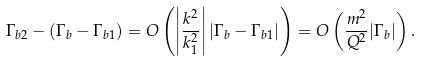<formula> <loc_0><loc_0><loc_500><loc_500>\Gamma _ { b 2 } - ( \Gamma _ { b } - \Gamma _ { b 1 } ) = O \left ( \left | \frac { k ^ { 2 } } { k _ { 1 } ^ { 2 } } \right | | \Gamma _ { b } - \Gamma _ { b 1 } | \right ) = O \left ( \frac { m ^ { 2 } } { Q ^ { 2 } } | \Gamma _ { b } | \right ) .</formula> 